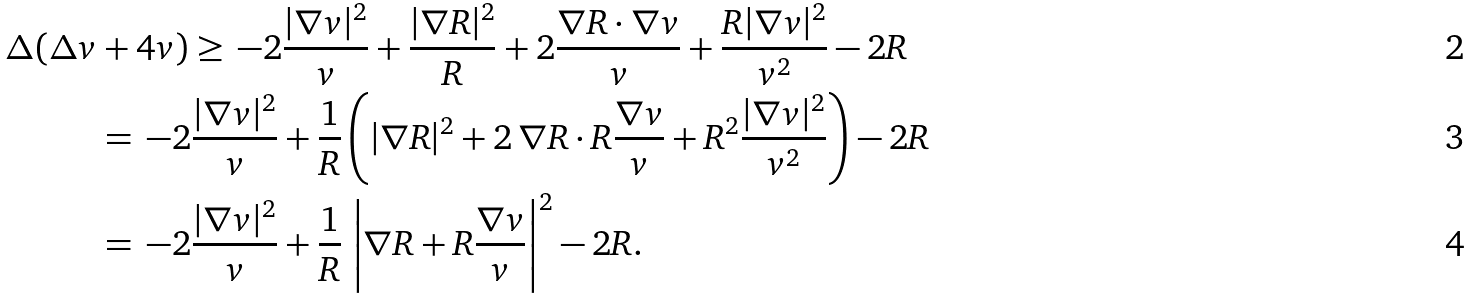<formula> <loc_0><loc_0><loc_500><loc_500>\Delta ( \Delta v & + 4 v ) \geq \, - 2 \frac { | \nabla v | ^ { 2 } } { v } + \frac { | \nabla R | ^ { 2 } } { R } + 2 \frac { \nabla R \cdot \nabla v } { v } + \frac { R | \nabla v | ^ { 2 } } { v ^ { 2 } } - 2 R \\ & = \, - 2 \frac { | \nabla v | ^ { 2 } } { v } + \frac { 1 } { R } \left ( | \nabla R | ^ { 2 } + 2 \, \nabla R \cdot R \frac { \nabla v } { v } + R ^ { 2 } \frac { | \nabla v | ^ { 2 } } { v ^ { 2 } } \right ) - 2 R \\ & = \, - 2 \frac { | \nabla v | ^ { 2 } } { v } + \frac { 1 } { R } \, \left | \nabla R + R \frac { \nabla v } { v } \right | ^ { 2 } - 2 R .</formula> 